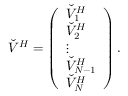Convert formula to latex. <formula><loc_0><loc_0><loc_500><loc_500>\check { V } ^ { H } = \left ( \begin{array} { l } { \check { V } _ { 1 } ^ { H } } \\ { \check { V } _ { 2 } ^ { H } } \\ { \vdots } \\ { \check { V } _ { N - 1 } ^ { H } } \\ { \check { V } _ { N } ^ { H } } \end{array} \right ) .</formula> 